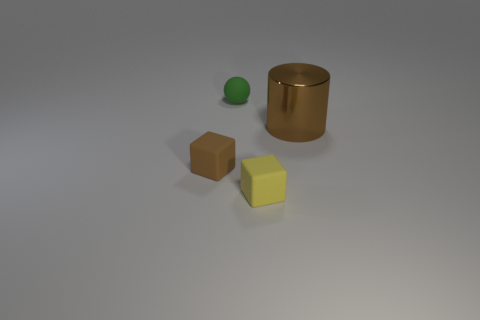Add 2 tiny green objects. How many objects exist? 6 Subtract all spheres. How many objects are left? 3 Subtract 0 purple cylinders. How many objects are left? 4 Subtract all yellow shiny spheres. Subtract all matte spheres. How many objects are left? 3 Add 1 big brown metal cylinders. How many big brown metal cylinders are left? 2 Add 1 brown blocks. How many brown blocks exist? 2 